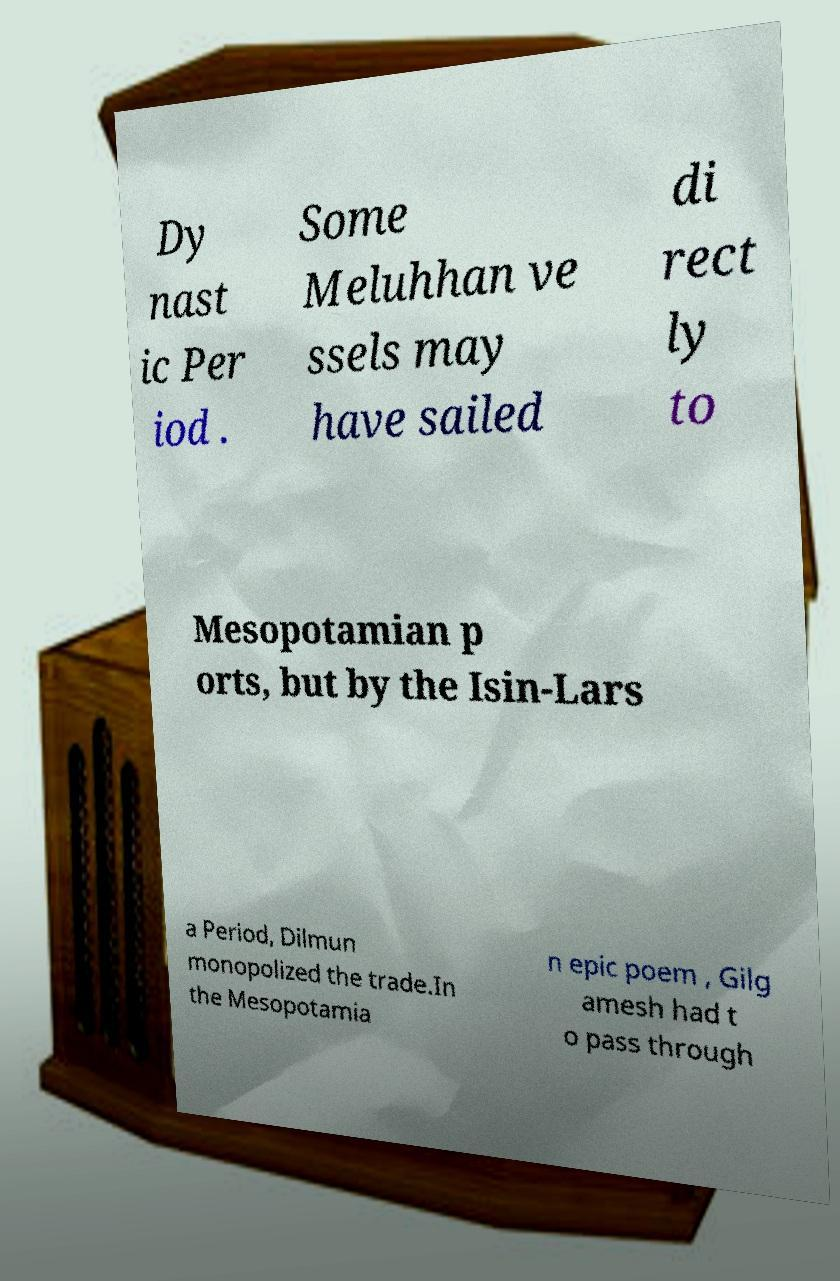Can you read and provide the text displayed in the image?This photo seems to have some interesting text. Can you extract and type it out for me? Dy nast ic Per iod . Some Meluhhan ve ssels may have sailed di rect ly to Mesopotamian p orts, but by the Isin-Lars a Period, Dilmun monopolized the trade.In the Mesopotamia n epic poem , Gilg amesh had t o pass through 